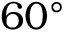<formula> <loc_0><loc_0><loc_500><loc_500>6 0 ^ { \circ }</formula> 